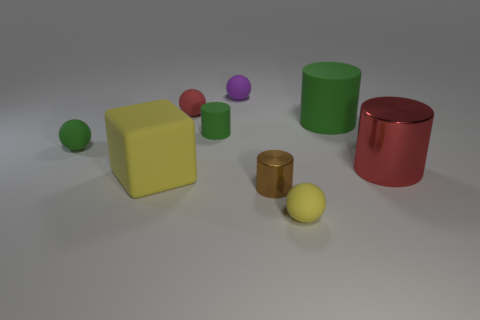Can you tell me the colors of all the spheres in the image? Certainly, from left to right, there's a green sphere, a pink sphere, a purple sphere, and finally, another which appears to be yellow. Each sphere is set apart from each other in the scene. Could you tell me if these spheres have glossy or matte finishes? Sure, based on the way the light interacts with them, the green and pink spheres have a matte finish, as they don't reflect much light. In contrast, the purple and yellow spheres possess a glossy finish, as evidenced by the bright highlights and reflections on their surfaces. 